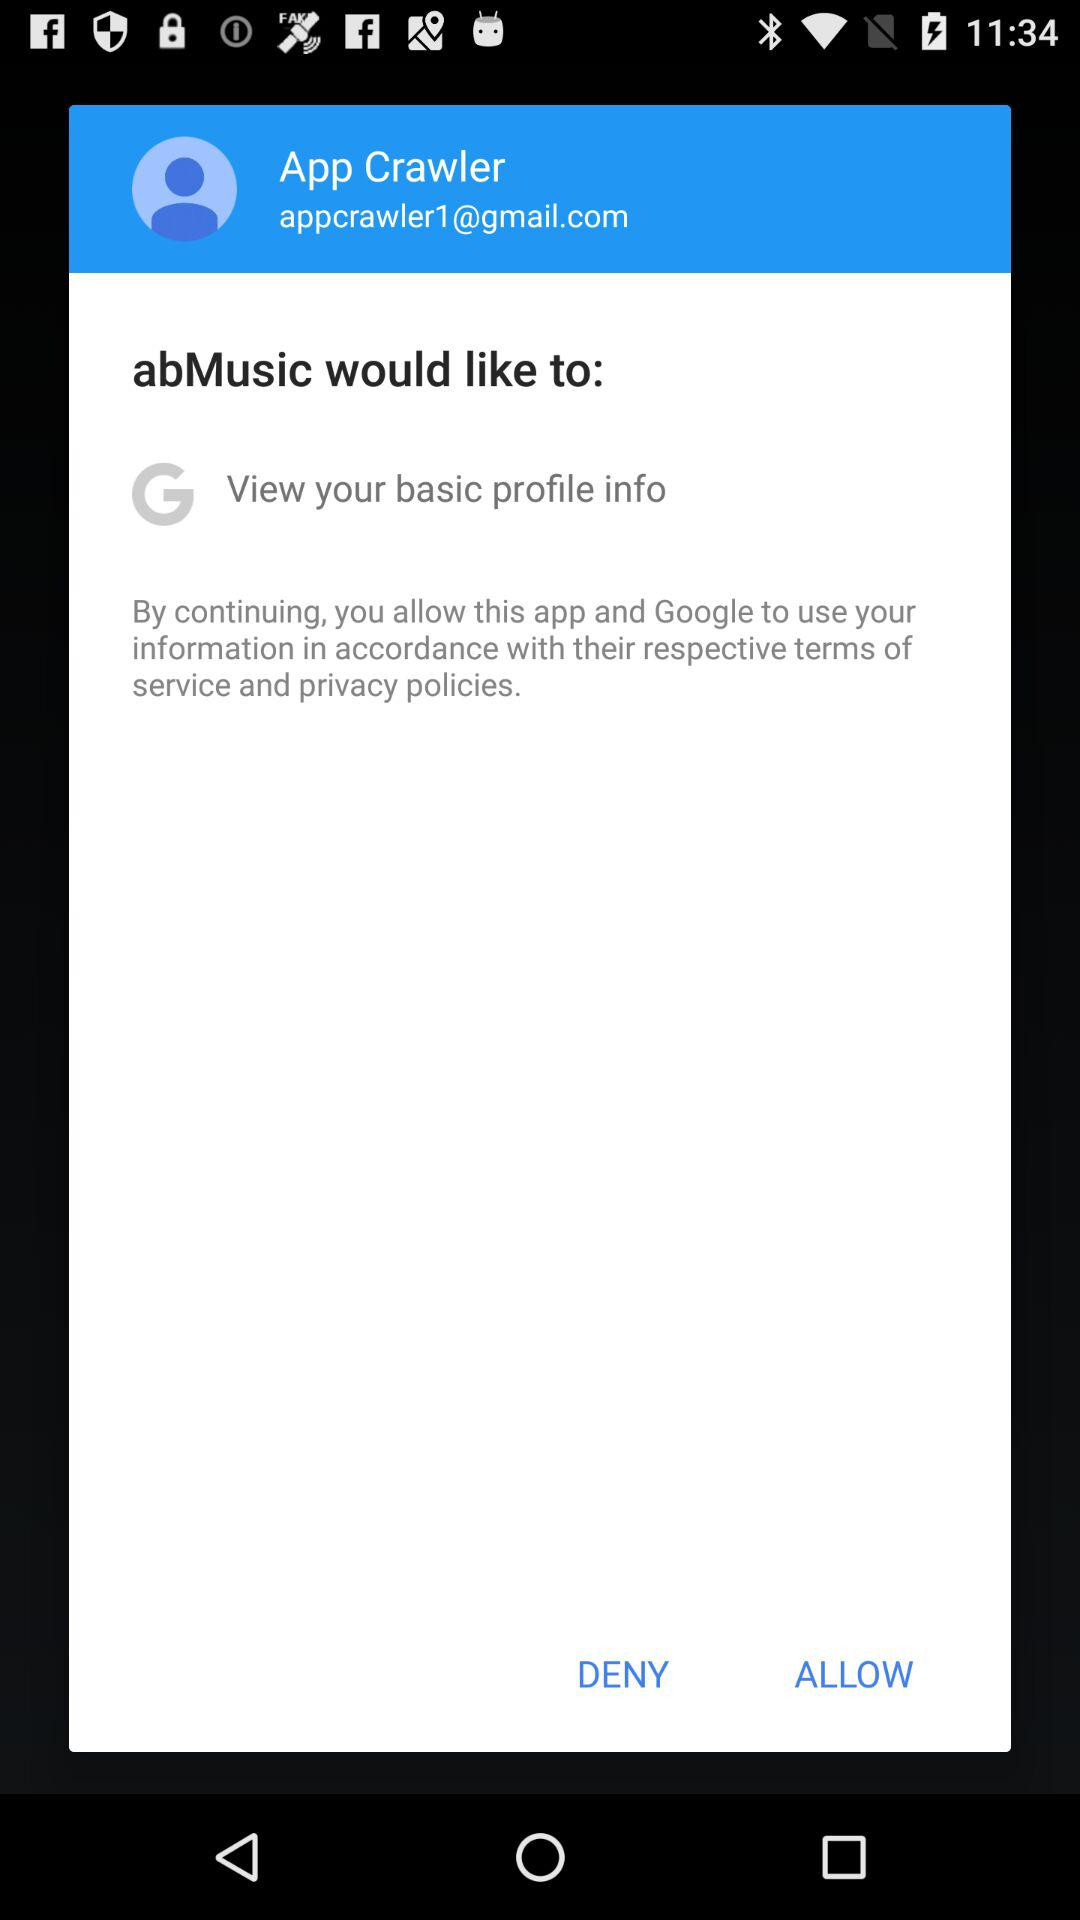What application is asking to view my basic profile information? The application is "abMusic". 